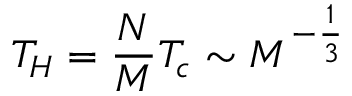<formula> <loc_0><loc_0><loc_500><loc_500>T _ { H } = \frac { N } { M } T _ { c } \sim M ^ { - \frac { 1 } { 3 } }</formula> 